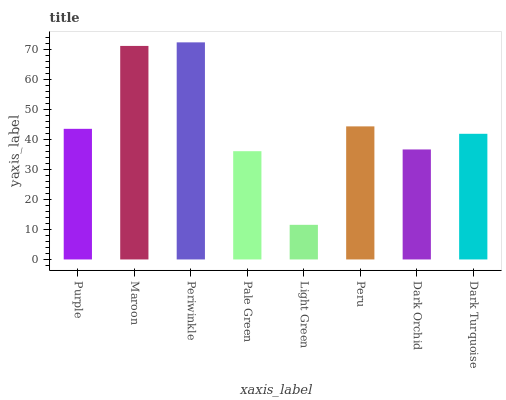Is Light Green the minimum?
Answer yes or no. Yes. Is Periwinkle the maximum?
Answer yes or no. Yes. Is Maroon the minimum?
Answer yes or no. No. Is Maroon the maximum?
Answer yes or no. No. Is Maroon greater than Purple?
Answer yes or no. Yes. Is Purple less than Maroon?
Answer yes or no. Yes. Is Purple greater than Maroon?
Answer yes or no. No. Is Maroon less than Purple?
Answer yes or no. No. Is Purple the high median?
Answer yes or no. Yes. Is Dark Turquoise the low median?
Answer yes or no. Yes. Is Maroon the high median?
Answer yes or no. No. Is Purple the low median?
Answer yes or no. No. 